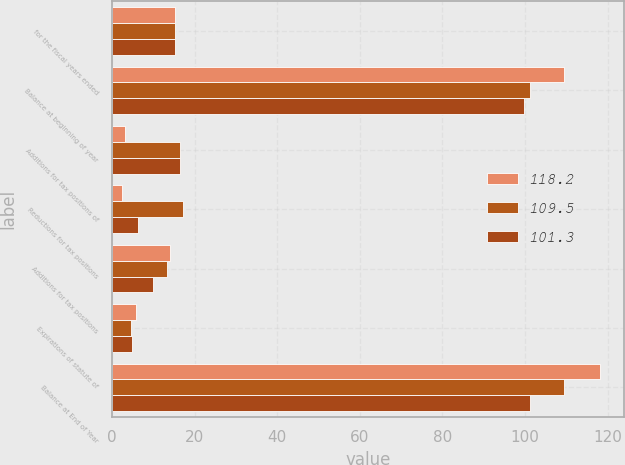Convert chart to OTSL. <chart><loc_0><loc_0><loc_500><loc_500><stacked_bar_chart><ecel><fcel>for the fiscal years ended<fcel>Balance at beginning of year<fcel>Additions for tax positions of<fcel>Reductions for tax positions<fcel>Additions for tax positions<fcel>Expirations of statute of<fcel>Balance at End of Year<nl><fcel>118.2<fcel>15.25<fcel>109.5<fcel>3<fcel>2.4<fcel>14.1<fcel>5.7<fcel>118.2<nl><fcel>109.5<fcel>15.25<fcel>101.3<fcel>16.5<fcel>17.1<fcel>13.4<fcel>4.6<fcel>109.5<nl><fcel>101.3<fcel>15.25<fcel>99.7<fcel>16.4<fcel>6.3<fcel>10<fcel>4.8<fcel>101.3<nl></chart> 